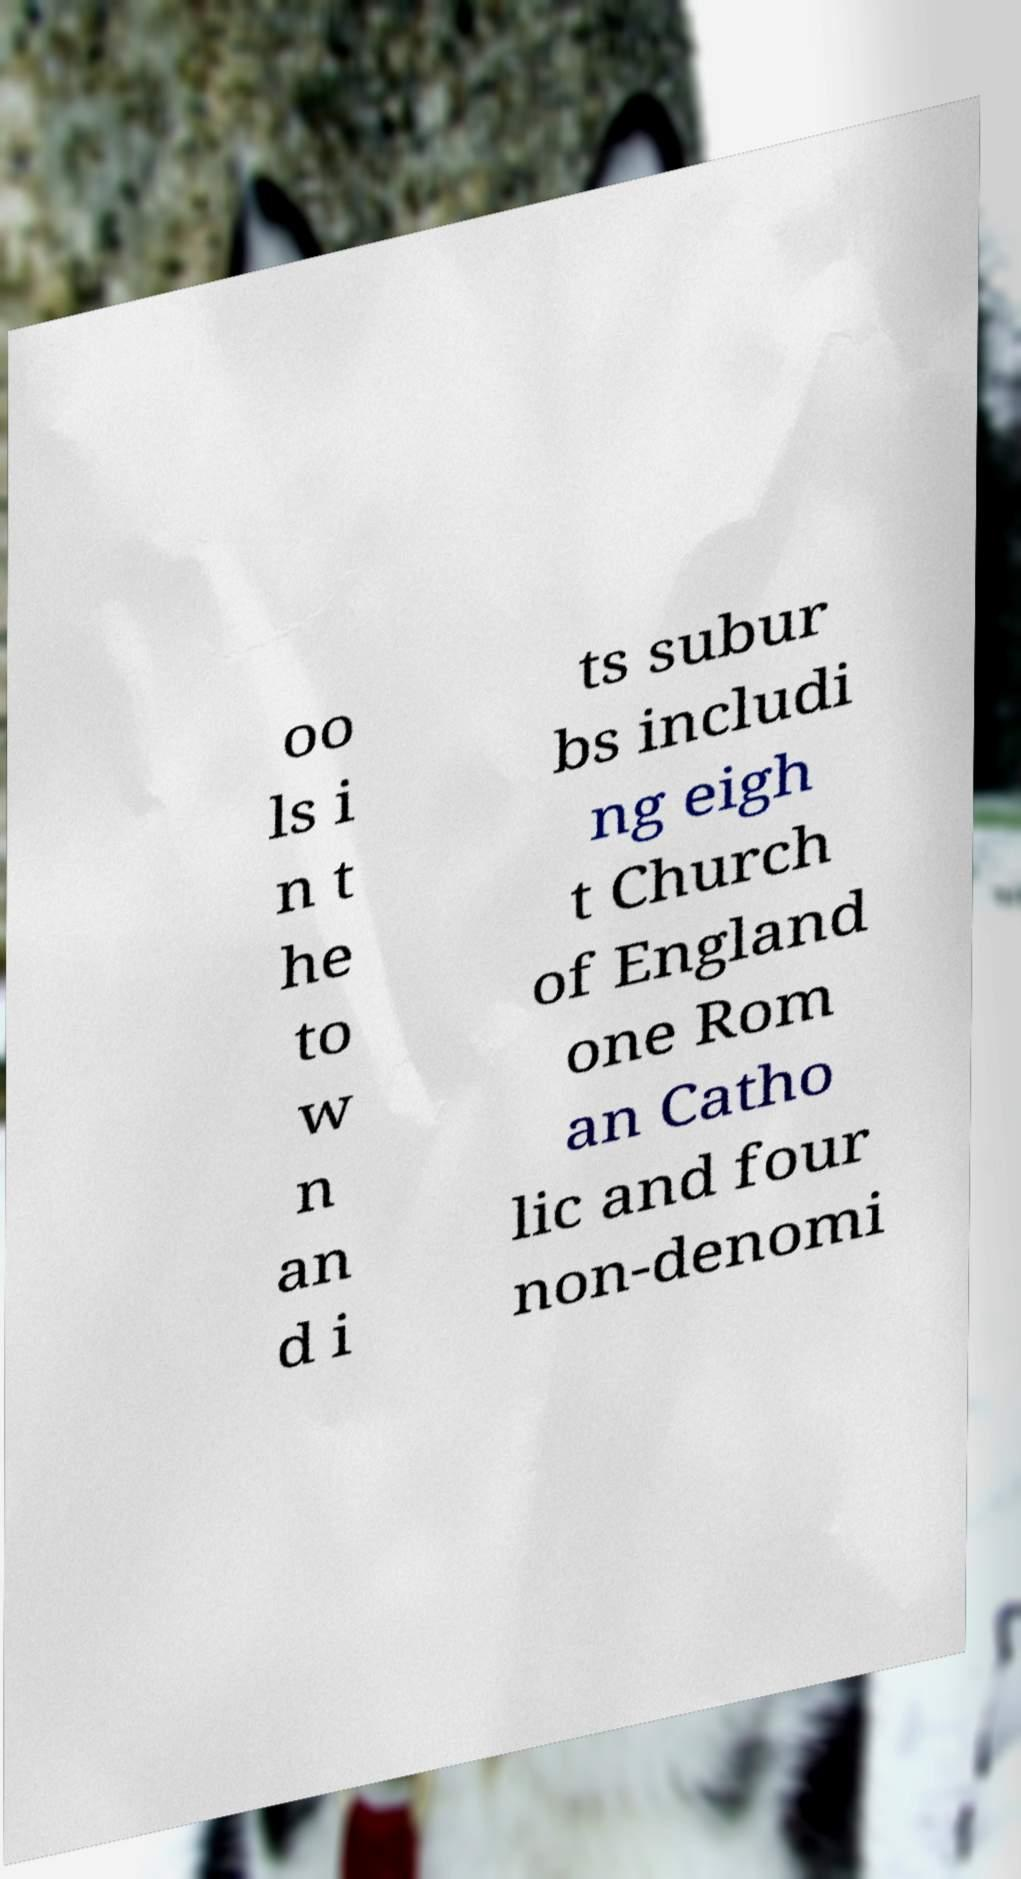Could you assist in decoding the text presented in this image and type it out clearly? oo ls i n t he to w n an d i ts subur bs includi ng eigh t Church of England one Rom an Catho lic and four non-denomi 